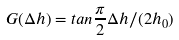<formula> <loc_0><loc_0><loc_500><loc_500>G ( \Delta h ) = t a n \frac { \pi } { 2 } \Delta h / ( 2 h _ { 0 } )</formula> 